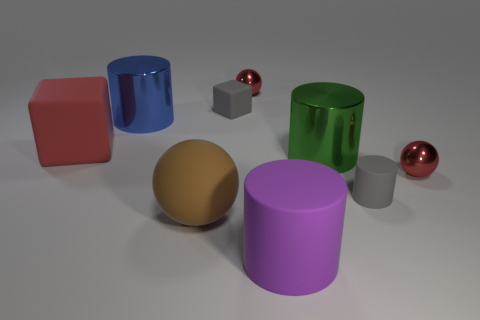Subtract 1 cylinders. How many cylinders are left? 3 Subtract all balls. How many objects are left? 6 Subtract all red metal spheres. Subtract all large red cubes. How many objects are left? 6 Add 4 large cylinders. How many large cylinders are left? 7 Add 4 large green shiny objects. How many large green shiny objects exist? 5 Subtract 0 yellow spheres. How many objects are left? 9 